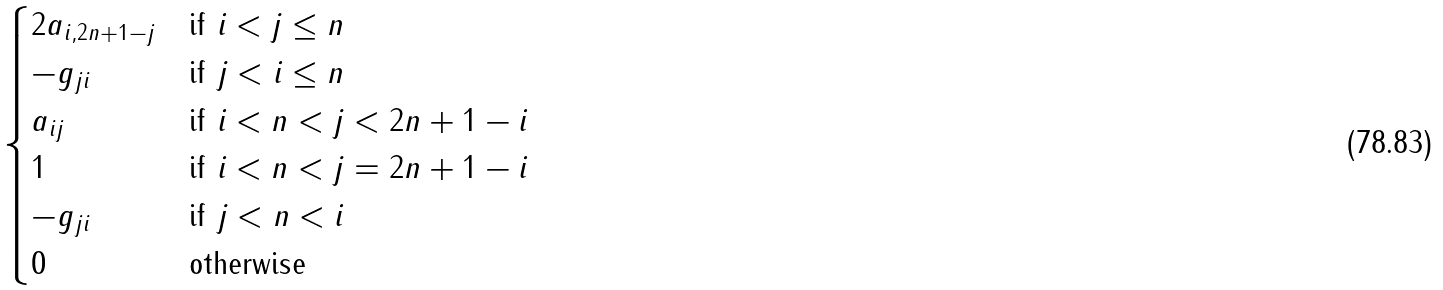Convert formula to latex. <formula><loc_0><loc_0><loc_500><loc_500>\begin{cases} 2 a _ { i , 2 n + 1 - j } & \text {if $i<j\leq n$} \\ - g _ { j i } & \text {if $j<i\leq n$} \\ a _ { i j } & \text {if $i<n<j<2n+1-i$} \\ 1 & \text {if $i<n<j= 2n+1-i$} \\ - g _ { j i } & \text {if $j<n<i$} \\ 0 & \text {otherwise} \end{cases}</formula> 